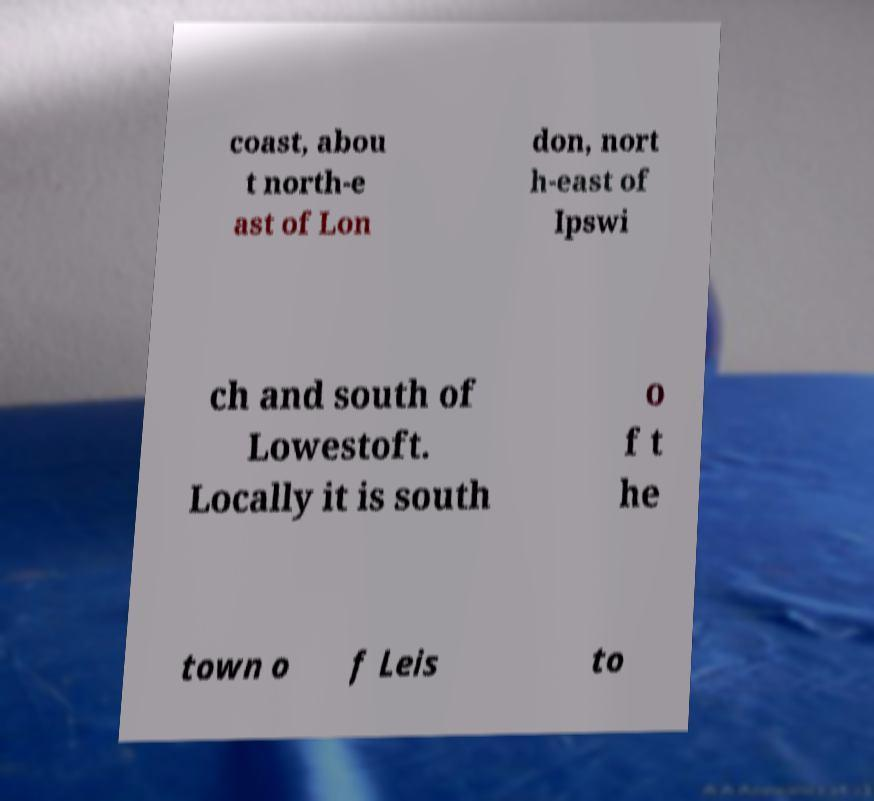Please identify and transcribe the text found in this image. coast, abou t north-e ast of Lon don, nort h-east of Ipswi ch and south of Lowestoft. Locally it is south o f t he town o f Leis to 